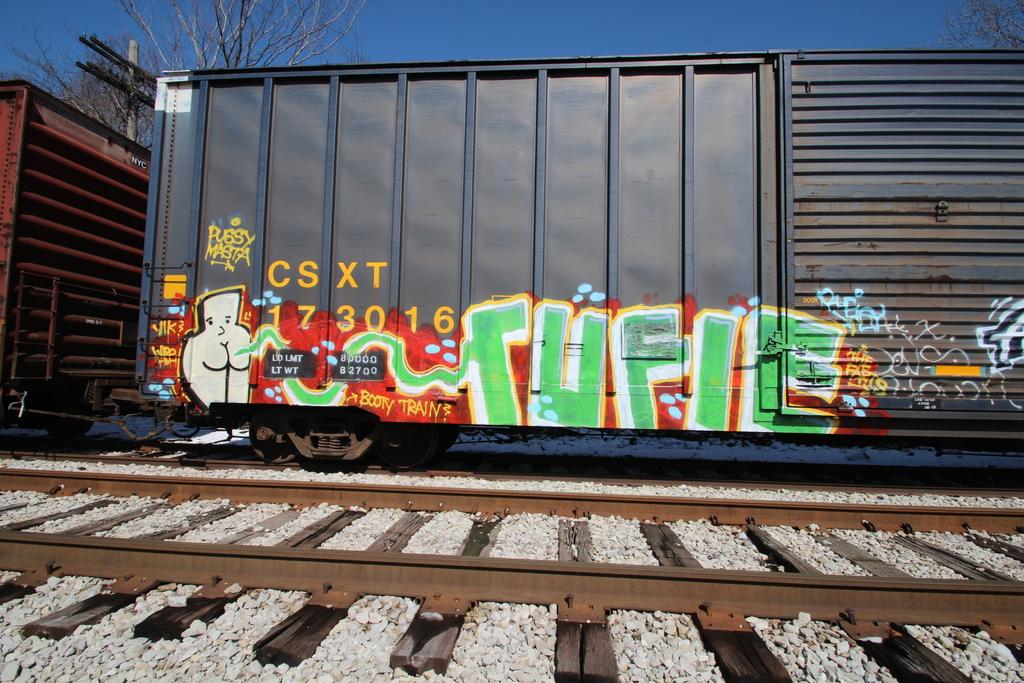<image>
Summarize the visual content of the image. The train car has been marked by graffiti, including a tag that says "booty train". 